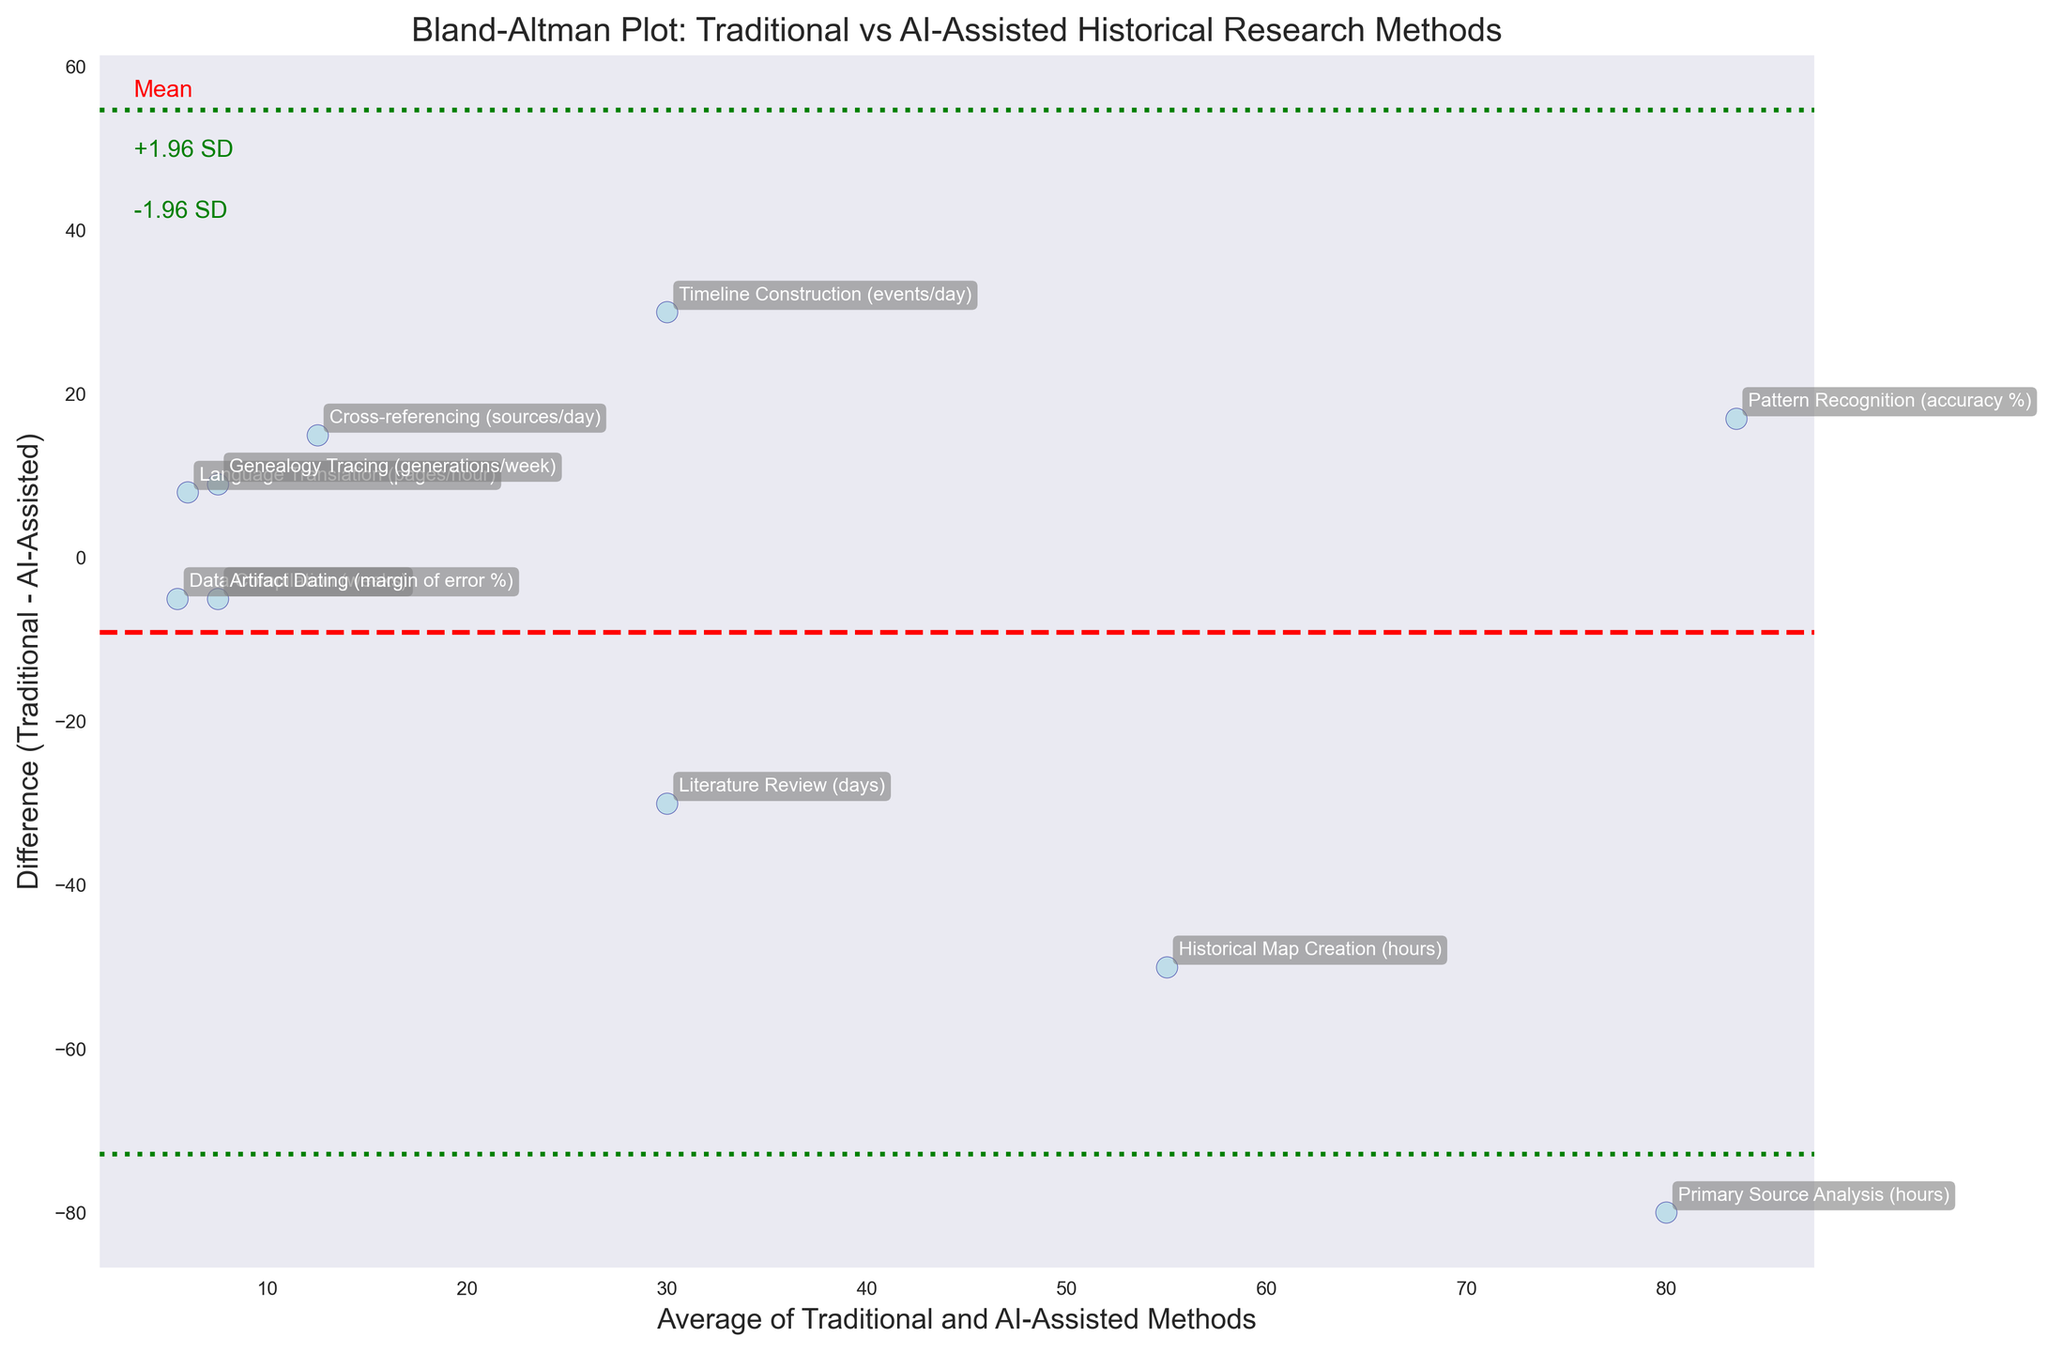What is the title of the plot? The title can be found at the top of the plot, which is written in a larger and bold font than other elements.
Answer: Bland-Altman Plot: Traditional vs AI-Assisted Historical Research Methods How many data points are there in the plot? Count the number of points ( markers) visually represented in the plot. Each point corresponds to a method listed in the data.
Answer: 10 What is the range of the y-axis? The y-axis range can be determined by looking at the lowest and highest values on the y-axis, indicated by the scale markings. The visible axis limits are from -80 to 30.
Answer: -80 to 30 What are the colors of the dots and their outlines in the plot? The dots are filled with light blue color, and their outlines are dark blue as visually observable.
Answer: Light blue (fill) and dark blue (outline) What is the mean difference line's color and style? The mean difference line is displayed in red color and styled as a dashed line.
Answer: Red and dashed Which methods have a positive difference (i.e., Traditional > AI-Assisted)? Identify the points above the zero line on the y-axis, which indicates a positive difference between Traditional and AI-Assisted methods. The positive points are Pattern Recognition, Cross-referencing, Language Translation, and Genealogy Tracing.
Answer: Pattern Recognition, Cross-referencing, Language Translation, and Genealogy Tracing What is the mean difference value? The mean difference line's y-value is the same across the plot and can be read from where it intersects the y-axis. The specific value is labeled nearby or inferred from context.
Answer: -3.1 Which method has the largest difference between Traditional and AI-Assisted? Find the data point with the highest absolute value on the y-axis since the y-axis shows the difference. The data point at -80 corresponds to Primary Source Analysis.
Answer: Primary Source Analysis What methods fall outside the 95% limits of agreement? Points falling outside the green dashed lines (+1.96 and -1.96 SD) indicate those methods. Visually identify these outliers based on the position relative to the green lines. The methods are Primary Source Analysis, Cross-referencing, and Timeline Construction.
Answer: Primary Source Analysis, Cross-referencing, and Timeline Construction What does the green dashed line represent in the plot? These lines denote the 95% limits of agreement, calculated as the mean difference ± 1.96 times the standard deviation of the difference. This means these limits capture where most differences lie, indicating agreement range.
Answer: 95% limits of agreement 